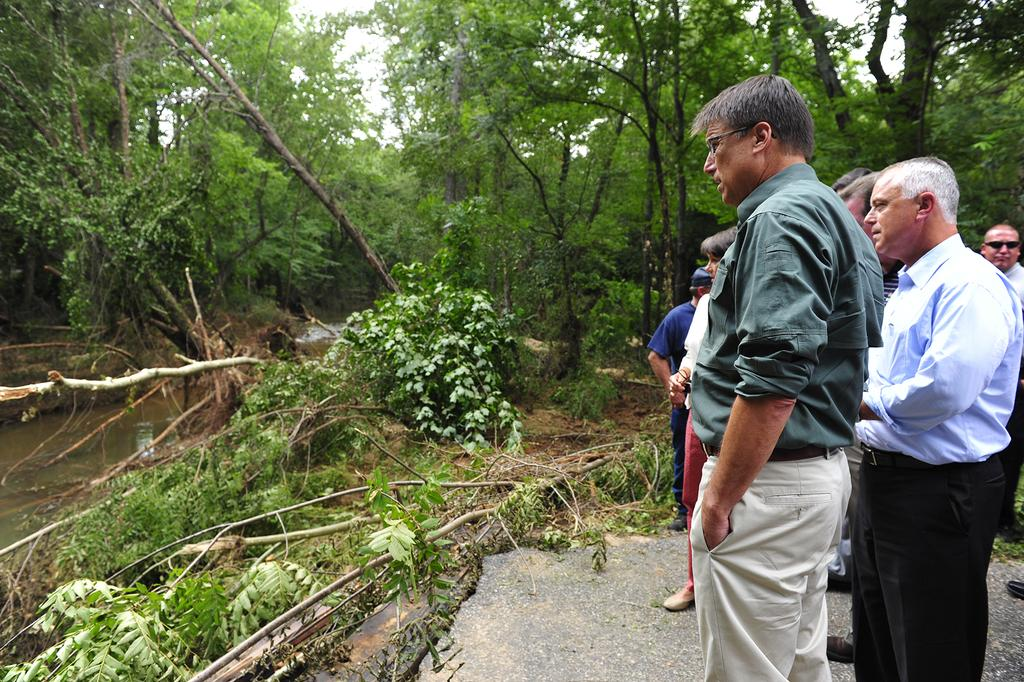What are the people in the image doing? The people in the image are standing on the road. What might have caused the people to be standing on the road? The presence of fallen trees on the ground suggests that there might have been a storm or some other event that caused the trees to fall. What can be seen in the image besides the people and fallen trees? There is water visible in the image, as well as trees and the sky in the background. What type of furniture can be seen floating in the water in the image? There is no furniture visible in the image; it only shows people standing on the road, fallen trees, water, and trees and the sky in the background. 